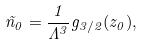<formula> <loc_0><loc_0><loc_500><loc_500>\tilde { n } _ { 0 } = \frac { 1 } { \Lambda ^ { 3 } } g _ { 3 / 2 } ( z _ { 0 } ) ,</formula> 